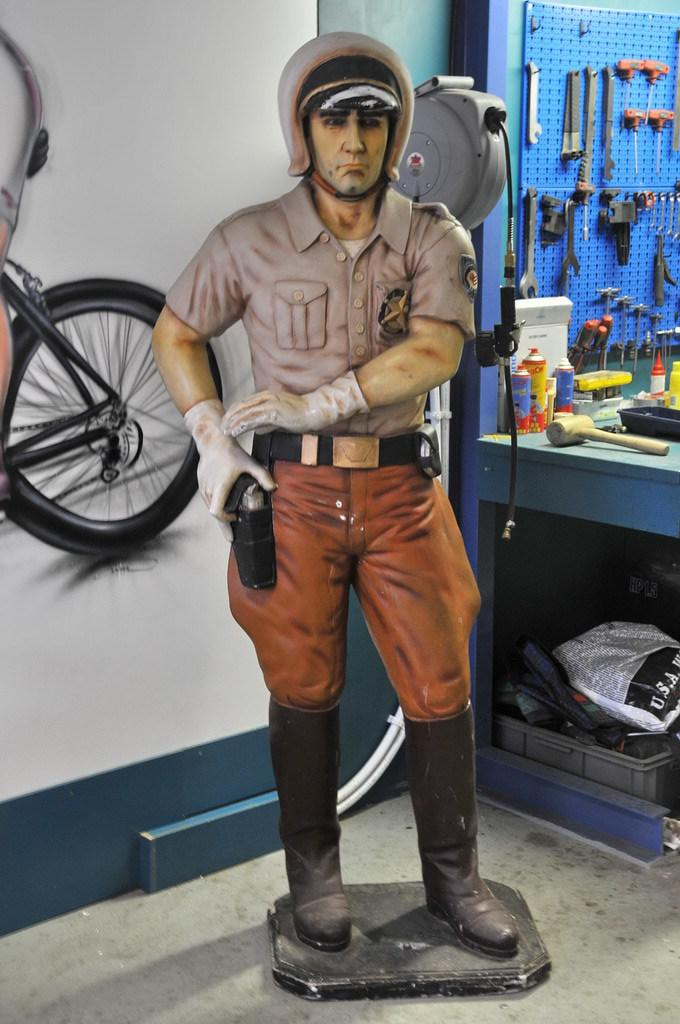What is the main subject in the image? There is a statue in the image. What else can be seen in the image besides the statue? There is a basket, a hammer, bottles, tools, and other objects in the image. Can you describe the tools in the image? There are tools in the image, but their specific types are not mentioned in the facts. What is depicted on the wall in the background? There is a picture of a wheel on the wall in the background. What type of bread is being used to build the statue in the image? There is no bread present in the image, and the statue is not being built. 